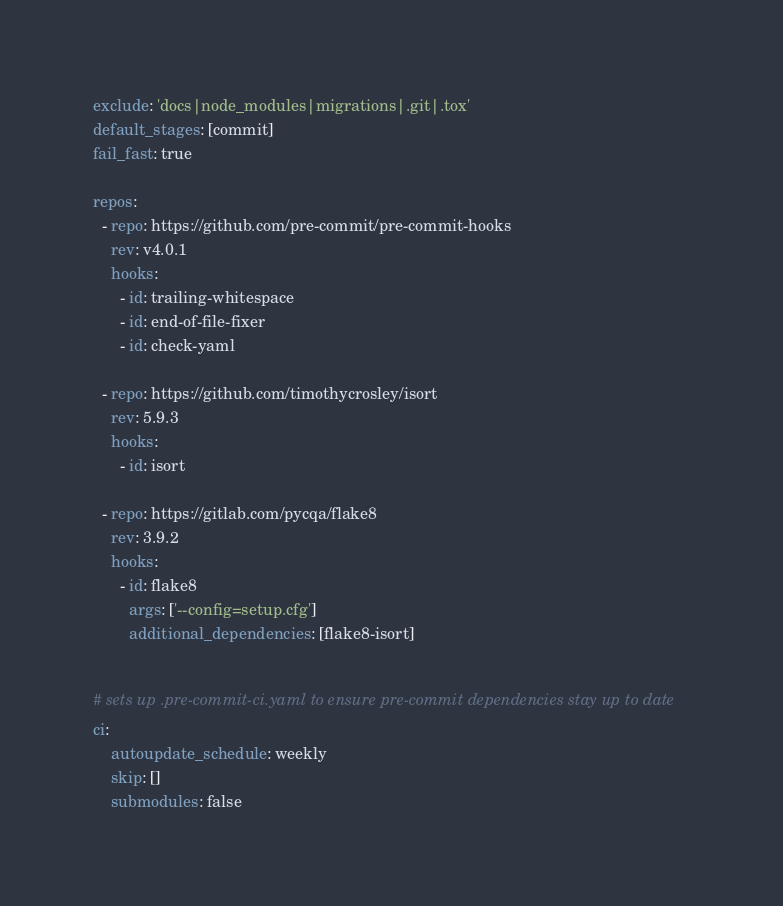<code> <loc_0><loc_0><loc_500><loc_500><_YAML_>exclude: 'docs|node_modules|migrations|.git|.tox'
default_stages: [commit]
fail_fast: true

repos:
  - repo: https://github.com/pre-commit/pre-commit-hooks
    rev: v4.0.1
    hooks:
      - id: trailing-whitespace
      - id: end-of-file-fixer
      - id: check-yaml

  - repo: https://github.com/timothycrosley/isort
    rev: 5.9.3
    hooks:
      - id: isort

  - repo: https://gitlab.com/pycqa/flake8
    rev: 3.9.2
    hooks:
      - id: flake8
        args: ['--config=setup.cfg']
        additional_dependencies: [flake8-isort]


# sets up .pre-commit-ci.yaml to ensure pre-commit dependencies stay up to date
ci:
    autoupdate_schedule: weekly
    skip: []
    submodules: false
</code> 